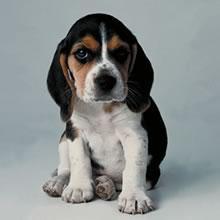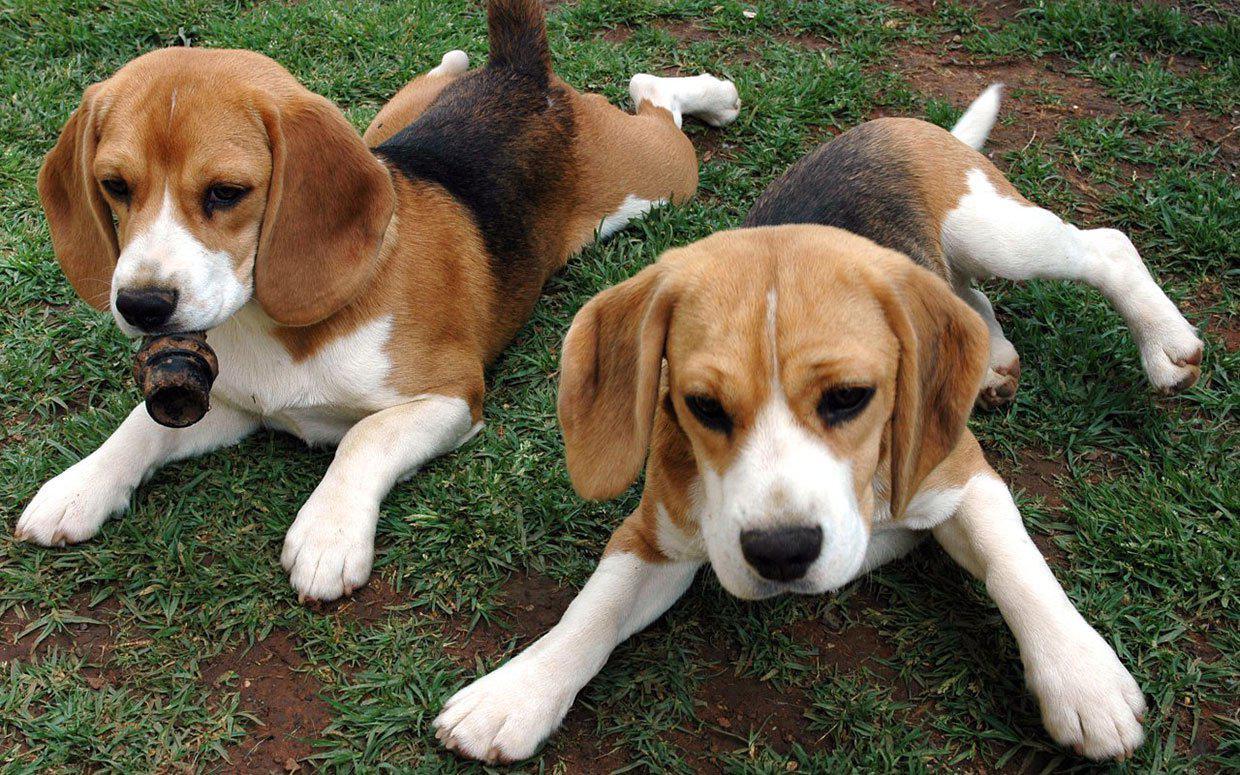The first image is the image on the left, the second image is the image on the right. Assess this claim about the two images: "There are no more than 3 puppies in total.". Correct or not? Answer yes or no. Yes. The first image is the image on the left, the second image is the image on the right. Assess this claim about the two images: "There are more dogs in the right image than in the left image.". Correct or not? Answer yes or no. Yes. 